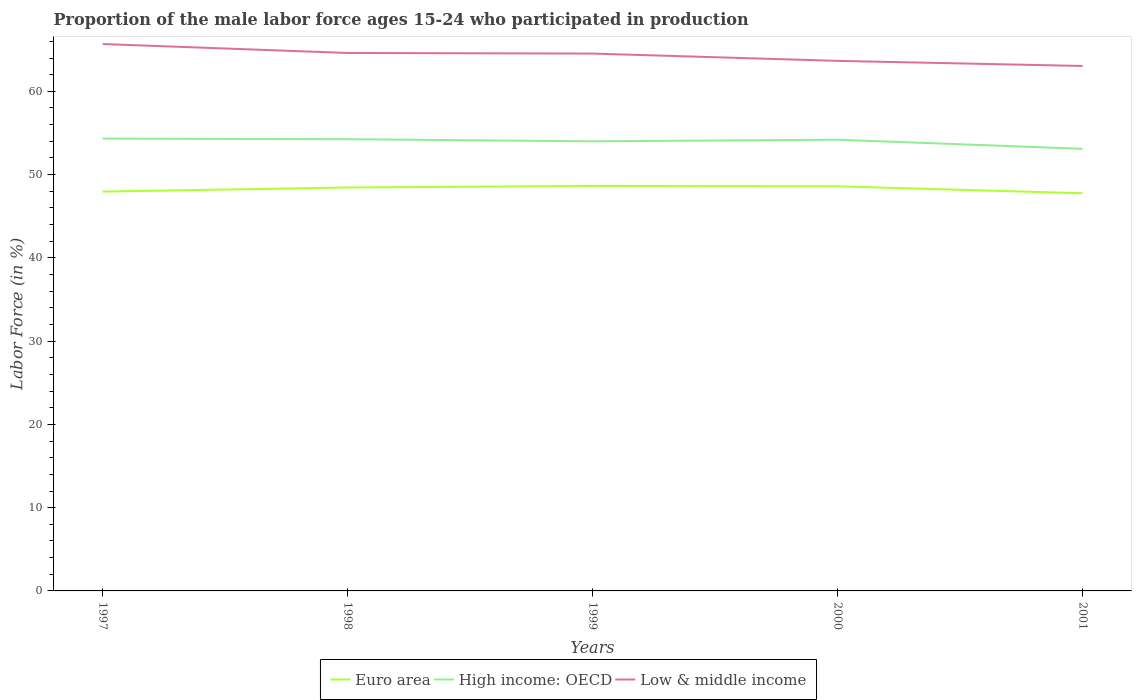Does the line corresponding to Low & middle income intersect with the line corresponding to Euro area?
Offer a very short reply. No. Across all years, what is the maximum proportion of the male labor force who participated in production in High income: OECD?
Keep it short and to the point. 53.09. What is the total proportion of the male labor force who participated in production in Euro area in the graph?
Provide a succinct answer. -0.68. What is the difference between the highest and the second highest proportion of the male labor force who participated in production in High income: OECD?
Make the answer very short. 1.23. What is the difference between the highest and the lowest proportion of the male labor force who participated in production in Low & middle income?
Ensure brevity in your answer.  3. How many years are there in the graph?
Make the answer very short. 5. Does the graph contain any zero values?
Make the answer very short. No. Does the graph contain grids?
Provide a succinct answer. No. Where does the legend appear in the graph?
Your answer should be very brief. Bottom center. How are the legend labels stacked?
Ensure brevity in your answer.  Horizontal. What is the title of the graph?
Provide a succinct answer. Proportion of the male labor force ages 15-24 who participated in production. Does "Zimbabwe" appear as one of the legend labels in the graph?
Your answer should be compact. No. What is the label or title of the X-axis?
Give a very brief answer. Years. What is the Labor Force (in %) in Euro area in 1997?
Offer a very short reply. 47.96. What is the Labor Force (in %) of High income: OECD in 1997?
Make the answer very short. 54.32. What is the Labor Force (in %) of Low & middle income in 1997?
Keep it short and to the point. 65.68. What is the Labor Force (in %) of Euro area in 1998?
Your answer should be compact. 48.45. What is the Labor Force (in %) in High income: OECD in 1998?
Your answer should be very brief. 54.25. What is the Labor Force (in %) in Low & middle income in 1998?
Your answer should be compact. 64.61. What is the Labor Force (in %) in Euro area in 1999?
Your answer should be very brief. 48.64. What is the Labor Force (in %) in High income: OECD in 1999?
Make the answer very short. 54. What is the Labor Force (in %) of Low & middle income in 1999?
Keep it short and to the point. 64.53. What is the Labor Force (in %) in Euro area in 2000?
Give a very brief answer. 48.59. What is the Labor Force (in %) in High income: OECD in 2000?
Ensure brevity in your answer.  54.19. What is the Labor Force (in %) of Low & middle income in 2000?
Provide a short and direct response. 63.66. What is the Labor Force (in %) of Euro area in 2001?
Your answer should be compact. 47.76. What is the Labor Force (in %) in High income: OECD in 2001?
Provide a short and direct response. 53.09. What is the Labor Force (in %) of Low & middle income in 2001?
Your answer should be very brief. 63.04. Across all years, what is the maximum Labor Force (in %) of Euro area?
Ensure brevity in your answer.  48.64. Across all years, what is the maximum Labor Force (in %) in High income: OECD?
Provide a short and direct response. 54.32. Across all years, what is the maximum Labor Force (in %) in Low & middle income?
Provide a short and direct response. 65.68. Across all years, what is the minimum Labor Force (in %) of Euro area?
Give a very brief answer. 47.76. Across all years, what is the minimum Labor Force (in %) in High income: OECD?
Your response must be concise. 53.09. Across all years, what is the minimum Labor Force (in %) in Low & middle income?
Ensure brevity in your answer.  63.04. What is the total Labor Force (in %) of Euro area in the graph?
Provide a short and direct response. 241.39. What is the total Labor Force (in %) in High income: OECD in the graph?
Provide a short and direct response. 269.85. What is the total Labor Force (in %) of Low & middle income in the graph?
Keep it short and to the point. 321.52. What is the difference between the Labor Force (in %) in Euro area in 1997 and that in 1998?
Keep it short and to the point. -0.49. What is the difference between the Labor Force (in %) in High income: OECD in 1997 and that in 1998?
Ensure brevity in your answer.  0.07. What is the difference between the Labor Force (in %) of Low & middle income in 1997 and that in 1998?
Ensure brevity in your answer.  1.07. What is the difference between the Labor Force (in %) in Euro area in 1997 and that in 1999?
Your answer should be compact. -0.68. What is the difference between the Labor Force (in %) in High income: OECD in 1997 and that in 1999?
Your answer should be very brief. 0.33. What is the difference between the Labor Force (in %) of Low & middle income in 1997 and that in 1999?
Offer a very short reply. 1.15. What is the difference between the Labor Force (in %) of Euro area in 1997 and that in 2000?
Offer a very short reply. -0.63. What is the difference between the Labor Force (in %) of High income: OECD in 1997 and that in 2000?
Your answer should be very brief. 0.13. What is the difference between the Labor Force (in %) in Low & middle income in 1997 and that in 2000?
Keep it short and to the point. 2.02. What is the difference between the Labor Force (in %) of Euro area in 1997 and that in 2001?
Your answer should be compact. 0.2. What is the difference between the Labor Force (in %) in High income: OECD in 1997 and that in 2001?
Offer a terse response. 1.23. What is the difference between the Labor Force (in %) of Low & middle income in 1997 and that in 2001?
Provide a short and direct response. 2.63. What is the difference between the Labor Force (in %) of Euro area in 1998 and that in 1999?
Keep it short and to the point. -0.19. What is the difference between the Labor Force (in %) in High income: OECD in 1998 and that in 1999?
Offer a terse response. 0.25. What is the difference between the Labor Force (in %) of Low & middle income in 1998 and that in 1999?
Provide a short and direct response. 0.07. What is the difference between the Labor Force (in %) in Euro area in 1998 and that in 2000?
Ensure brevity in your answer.  -0.14. What is the difference between the Labor Force (in %) of High income: OECD in 1998 and that in 2000?
Keep it short and to the point. 0.06. What is the difference between the Labor Force (in %) in Low & middle income in 1998 and that in 2000?
Make the answer very short. 0.95. What is the difference between the Labor Force (in %) of Euro area in 1998 and that in 2001?
Give a very brief answer. 0.69. What is the difference between the Labor Force (in %) of High income: OECD in 1998 and that in 2001?
Keep it short and to the point. 1.15. What is the difference between the Labor Force (in %) of Low & middle income in 1998 and that in 2001?
Your response must be concise. 1.56. What is the difference between the Labor Force (in %) in Euro area in 1999 and that in 2000?
Give a very brief answer. 0.05. What is the difference between the Labor Force (in %) in High income: OECD in 1999 and that in 2000?
Provide a short and direct response. -0.19. What is the difference between the Labor Force (in %) in Low & middle income in 1999 and that in 2000?
Make the answer very short. 0.87. What is the difference between the Labor Force (in %) of Euro area in 1999 and that in 2001?
Make the answer very short. 0.88. What is the difference between the Labor Force (in %) in High income: OECD in 1999 and that in 2001?
Provide a succinct answer. 0.9. What is the difference between the Labor Force (in %) of Low & middle income in 1999 and that in 2001?
Give a very brief answer. 1.49. What is the difference between the Labor Force (in %) in Euro area in 2000 and that in 2001?
Keep it short and to the point. 0.83. What is the difference between the Labor Force (in %) of High income: OECD in 2000 and that in 2001?
Your answer should be very brief. 1.1. What is the difference between the Labor Force (in %) in Low & middle income in 2000 and that in 2001?
Make the answer very short. 0.61. What is the difference between the Labor Force (in %) in Euro area in 1997 and the Labor Force (in %) in High income: OECD in 1998?
Keep it short and to the point. -6.29. What is the difference between the Labor Force (in %) in Euro area in 1997 and the Labor Force (in %) in Low & middle income in 1998?
Offer a very short reply. -16.65. What is the difference between the Labor Force (in %) of High income: OECD in 1997 and the Labor Force (in %) of Low & middle income in 1998?
Your answer should be compact. -10.28. What is the difference between the Labor Force (in %) of Euro area in 1997 and the Labor Force (in %) of High income: OECD in 1999?
Offer a very short reply. -6.04. What is the difference between the Labor Force (in %) in Euro area in 1997 and the Labor Force (in %) in Low & middle income in 1999?
Provide a succinct answer. -16.57. What is the difference between the Labor Force (in %) in High income: OECD in 1997 and the Labor Force (in %) in Low & middle income in 1999?
Your response must be concise. -10.21. What is the difference between the Labor Force (in %) of Euro area in 1997 and the Labor Force (in %) of High income: OECD in 2000?
Offer a very short reply. -6.23. What is the difference between the Labor Force (in %) of Euro area in 1997 and the Labor Force (in %) of Low & middle income in 2000?
Provide a short and direct response. -15.7. What is the difference between the Labor Force (in %) in High income: OECD in 1997 and the Labor Force (in %) in Low & middle income in 2000?
Make the answer very short. -9.33. What is the difference between the Labor Force (in %) of Euro area in 1997 and the Labor Force (in %) of High income: OECD in 2001?
Keep it short and to the point. -5.13. What is the difference between the Labor Force (in %) in Euro area in 1997 and the Labor Force (in %) in Low & middle income in 2001?
Ensure brevity in your answer.  -15.09. What is the difference between the Labor Force (in %) of High income: OECD in 1997 and the Labor Force (in %) of Low & middle income in 2001?
Your response must be concise. -8.72. What is the difference between the Labor Force (in %) in Euro area in 1998 and the Labor Force (in %) in High income: OECD in 1999?
Offer a very short reply. -5.55. What is the difference between the Labor Force (in %) in Euro area in 1998 and the Labor Force (in %) in Low & middle income in 1999?
Your response must be concise. -16.08. What is the difference between the Labor Force (in %) of High income: OECD in 1998 and the Labor Force (in %) of Low & middle income in 1999?
Keep it short and to the point. -10.28. What is the difference between the Labor Force (in %) of Euro area in 1998 and the Labor Force (in %) of High income: OECD in 2000?
Provide a succinct answer. -5.74. What is the difference between the Labor Force (in %) of Euro area in 1998 and the Labor Force (in %) of Low & middle income in 2000?
Give a very brief answer. -15.21. What is the difference between the Labor Force (in %) in High income: OECD in 1998 and the Labor Force (in %) in Low & middle income in 2000?
Your answer should be very brief. -9.41. What is the difference between the Labor Force (in %) in Euro area in 1998 and the Labor Force (in %) in High income: OECD in 2001?
Provide a succinct answer. -4.64. What is the difference between the Labor Force (in %) in Euro area in 1998 and the Labor Force (in %) in Low & middle income in 2001?
Your answer should be compact. -14.59. What is the difference between the Labor Force (in %) of High income: OECD in 1998 and the Labor Force (in %) of Low & middle income in 2001?
Give a very brief answer. -8.8. What is the difference between the Labor Force (in %) in Euro area in 1999 and the Labor Force (in %) in High income: OECD in 2000?
Keep it short and to the point. -5.55. What is the difference between the Labor Force (in %) in Euro area in 1999 and the Labor Force (in %) in Low & middle income in 2000?
Provide a succinct answer. -15.02. What is the difference between the Labor Force (in %) in High income: OECD in 1999 and the Labor Force (in %) in Low & middle income in 2000?
Ensure brevity in your answer.  -9.66. What is the difference between the Labor Force (in %) of Euro area in 1999 and the Labor Force (in %) of High income: OECD in 2001?
Your answer should be compact. -4.46. What is the difference between the Labor Force (in %) of Euro area in 1999 and the Labor Force (in %) of Low & middle income in 2001?
Provide a succinct answer. -14.41. What is the difference between the Labor Force (in %) in High income: OECD in 1999 and the Labor Force (in %) in Low & middle income in 2001?
Make the answer very short. -9.05. What is the difference between the Labor Force (in %) of Euro area in 2000 and the Labor Force (in %) of High income: OECD in 2001?
Make the answer very short. -4.5. What is the difference between the Labor Force (in %) of Euro area in 2000 and the Labor Force (in %) of Low & middle income in 2001?
Make the answer very short. -14.45. What is the difference between the Labor Force (in %) in High income: OECD in 2000 and the Labor Force (in %) in Low & middle income in 2001?
Offer a terse response. -8.86. What is the average Labor Force (in %) of Euro area per year?
Provide a short and direct response. 48.28. What is the average Labor Force (in %) in High income: OECD per year?
Provide a succinct answer. 53.97. What is the average Labor Force (in %) in Low & middle income per year?
Keep it short and to the point. 64.3. In the year 1997, what is the difference between the Labor Force (in %) in Euro area and Labor Force (in %) in High income: OECD?
Your answer should be very brief. -6.36. In the year 1997, what is the difference between the Labor Force (in %) of Euro area and Labor Force (in %) of Low & middle income?
Provide a succinct answer. -17.72. In the year 1997, what is the difference between the Labor Force (in %) in High income: OECD and Labor Force (in %) in Low & middle income?
Offer a terse response. -11.36. In the year 1998, what is the difference between the Labor Force (in %) of Euro area and Labor Force (in %) of High income: OECD?
Provide a short and direct response. -5.8. In the year 1998, what is the difference between the Labor Force (in %) in Euro area and Labor Force (in %) in Low & middle income?
Provide a succinct answer. -16.16. In the year 1998, what is the difference between the Labor Force (in %) of High income: OECD and Labor Force (in %) of Low & middle income?
Offer a very short reply. -10.36. In the year 1999, what is the difference between the Labor Force (in %) of Euro area and Labor Force (in %) of High income: OECD?
Make the answer very short. -5.36. In the year 1999, what is the difference between the Labor Force (in %) of Euro area and Labor Force (in %) of Low & middle income?
Offer a terse response. -15.9. In the year 1999, what is the difference between the Labor Force (in %) of High income: OECD and Labor Force (in %) of Low & middle income?
Your response must be concise. -10.53. In the year 2000, what is the difference between the Labor Force (in %) of Euro area and Labor Force (in %) of High income: OECD?
Offer a terse response. -5.6. In the year 2000, what is the difference between the Labor Force (in %) in Euro area and Labor Force (in %) in Low & middle income?
Keep it short and to the point. -15.07. In the year 2000, what is the difference between the Labor Force (in %) in High income: OECD and Labor Force (in %) in Low & middle income?
Provide a short and direct response. -9.47. In the year 2001, what is the difference between the Labor Force (in %) in Euro area and Labor Force (in %) in High income: OECD?
Make the answer very short. -5.34. In the year 2001, what is the difference between the Labor Force (in %) of Euro area and Labor Force (in %) of Low & middle income?
Your response must be concise. -15.29. In the year 2001, what is the difference between the Labor Force (in %) in High income: OECD and Labor Force (in %) in Low & middle income?
Make the answer very short. -9.95. What is the ratio of the Labor Force (in %) in High income: OECD in 1997 to that in 1998?
Your answer should be compact. 1. What is the ratio of the Labor Force (in %) of Low & middle income in 1997 to that in 1998?
Keep it short and to the point. 1.02. What is the ratio of the Labor Force (in %) of Euro area in 1997 to that in 1999?
Your response must be concise. 0.99. What is the ratio of the Labor Force (in %) in High income: OECD in 1997 to that in 1999?
Ensure brevity in your answer.  1.01. What is the ratio of the Labor Force (in %) in Low & middle income in 1997 to that in 1999?
Offer a terse response. 1.02. What is the ratio of the Labor Force (in %) of Low & middle income in 1997 to that in 2000?
Provide a succinct answer. 1.03. What is the ratio of the Labor Force (in %) in High income: OECD in 1997 to that in 2001?
Give a very brief answer. 1.02. What is the ratio of the Labor Force (in %) in Low & middle income in 1997 to that in 2001?
Your response must be concise. 1.04. What is the ratio of the Labor Force (in %) of High income: OECD in 1998 to that in 1999?
Your answer should be very brief. 1. What is the ratio of the Labor Force (in %) in Low & middle income in 1998 to that in 1999?
Offer a terse response. 1. What is the ratio of the Labor Force (in %) of Euro area in 1998 to that in 2000?
Ensure brevity in your answer.  1. What is the ratio of the Labor Force (in %) in High income: OECD in 1998 to that in 2000?
Offer a very short reply. 1. What is the ratio of the Labor Force (in %) in Low & middle income in 1998 to that in 2000?
Keep it short and to the point. 1.01. What is the ratio of the Labor Force (in %) of Euro area in 1998 to that in 2001?
Provide a succinct answer. 1.01. What is the ratio of the Labor Force (in %) in High income: OECD in 1998 to that in 2001?
Keep it short and to the point. 1.02. What is the ratio of the Labor Force (in %) in Low & middle income in 1998 to that in 2001?
Ensure brevity in your answer.  1.02. What is the ratio of the Labor Force (in %) of Low & middle income in 1999 to that in 2000?
Your answer should be very brief. 1.01. What is the ratio of the Labor Force (in %) of Euro area in 1999 to that in 2001?
Your response must be concise. 1.02. What is the ratio of the Labor Force (in %) in Low & middle income in 1999 to that in 2001?
Give a very brief answer. 1.02. What is the ratio of the Labor Force (in %) in Euro area in 2000 to that in 2001?
Your answer should be very brief. 1.02. What is the ratio of the Labor Force (in %) of High income: OECD in 2000 to that in 2001?
Ensure brevity in your answer.  1.02. What is the ratio of the Labor Force (in %) of Low & middle income in 2000 to that in 2001?
Offer a very short reply. 1.01. What is the difference between the highest and the second highest Labor Force (in %) of Euro area?
Provide a succinct answer. 0.05. What is the difference between the highest and the second highest Labor Force (in %) in High income: OECD?
Provide a short and direct response. 0.07. What is the difference between the highest and the second highest Labor Force (in %) of Low & middle income?
Provide a short and direct response. 1.07. What is the difference between the highest and the lowest Labor Force (in %) of Euro area?
Your response must be concise. 0.88. What is the difference between the highest and the lowest Labor Force (in %) of High income: OECD?
Give a very brief answer. 1.23. What is the difference between the highest and the lowest Labor Force (in %) in Low & middle income?
Provide a short and direct response. 2.63. 